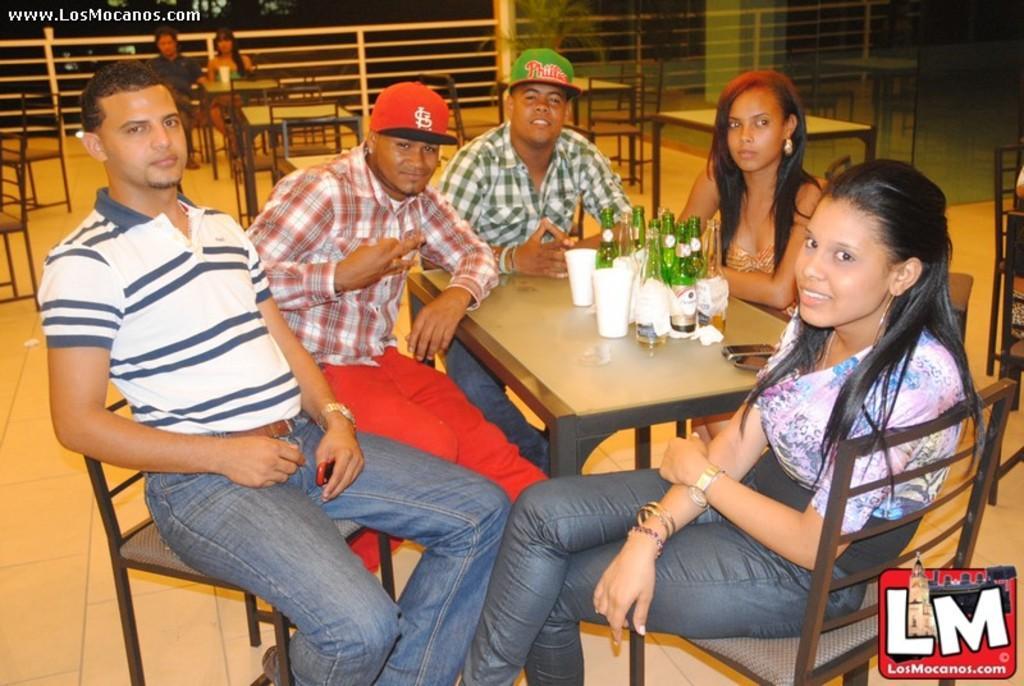Describe this image in one or two sentences. People are sitting on the chairs,there are bottles on the table. 